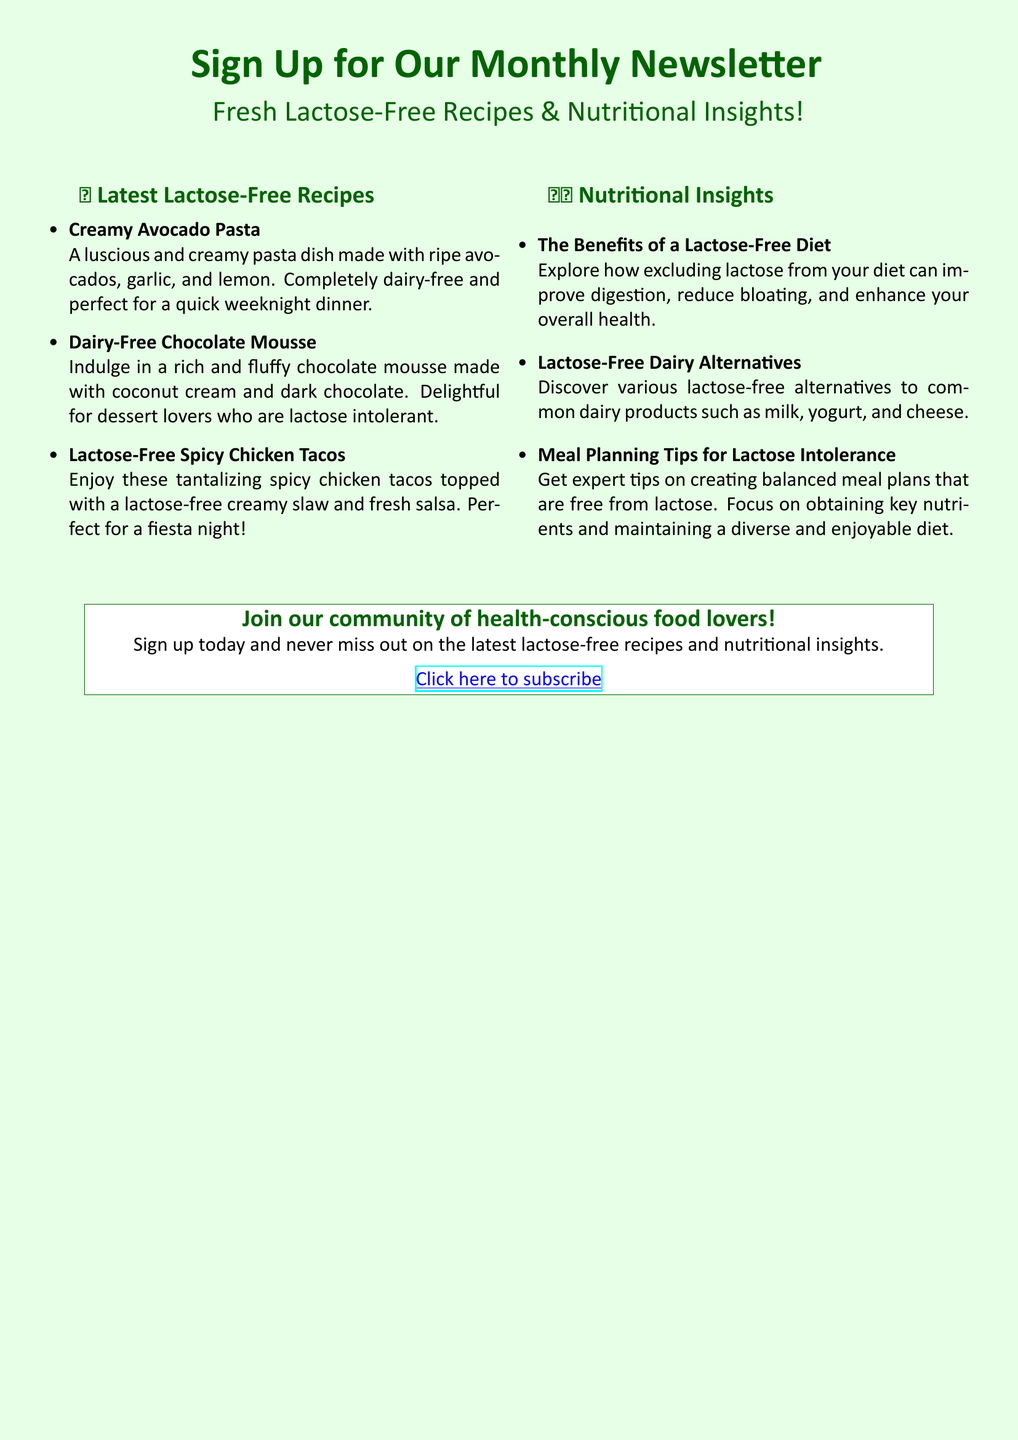What is the title of the newsletter? The title of the newsletter is clearly stated at the top of the document.
Answer: Sign Up for Our Monthly Newsletter What is one recipe mentioned in the document? The document lists several lactose-free recipes in the section titled "Latest Lactose-Free Recipes."
Answer: Creamy Avocado Pasta How many recipes are provided in the document? The total count of recipes can be found by counting the items listed under "Latest Lactose-Free Recipes."
Answer: Three What is a benefit of a lactose-free diet mentioned? The document discusses the benefits in the "Nutritional Insights" section, which contains specific advantages of a lactose-free diet.
Answer: Improve digestion What type of dessert is featured among the recipes? One of the recipes categorized as a dessert is highlighted within the "Latest Lactose-Free Recipes."
Answer: Dairy-Free Chocolate Mousse What is advised for meal planning? The document offers guidelines in the "Nutritional Insights" section specifically for those with dietary restrictions.
Answer: Balanced meal plans How can someone subscribe to the newsletter? The document provides a link to the subscription at the bottom of the page.
Answer: Click here to subscribe How many insights are described in the Nutritional Insights section? The number of insights can be determined by counting each item listed under the "Nutritional Insights" heading.
Answer: Three 